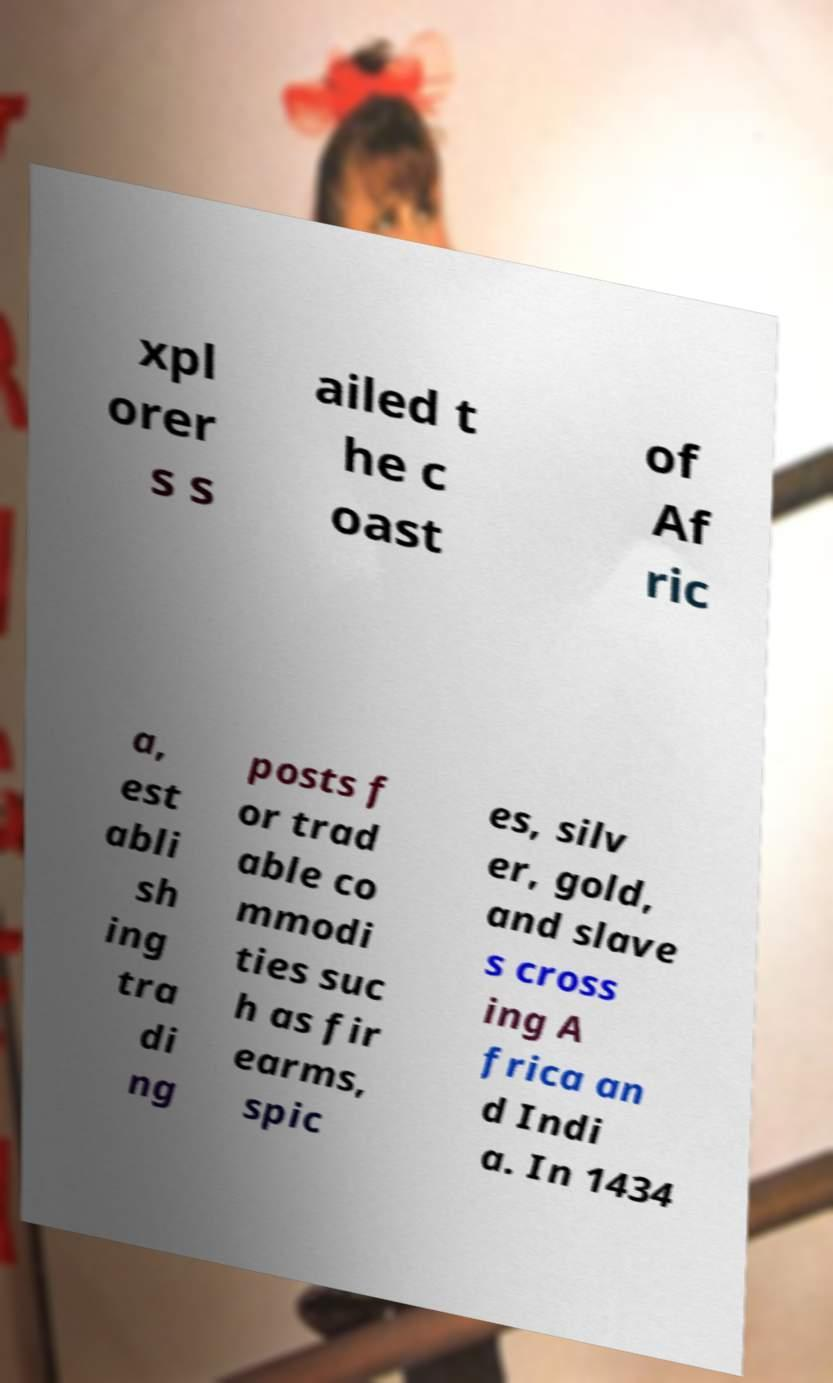Could you extract and type out the text from this image? xpl orer s s ailed t he c oast of Af ric a, est abli sh ing tra di ng posts f or trad able co mmodi ties suc h as fir earms, spic es, silv er, gold, and slave s cross ing A frica an d Indi a. In 1434 